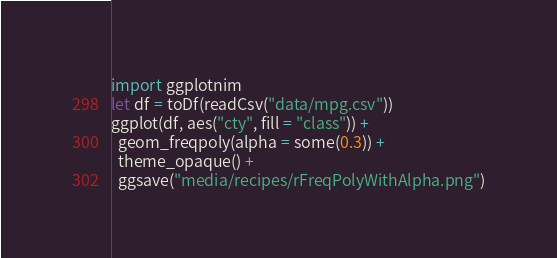Convert code to text. <code><loc_0><loc_0><loc_500><loc_500><_Nim_>import ggplotnim
let df = toDf(readCsv("data/mpg.csv"))
ggplot(df, aes("cty", fill = "class")) + 
  geom_freqpoly(alpha = some(0.3)) + 
  theme_opaque() +
  ggsave("media/recipes/rFreqPolyWithAlpha.png")
</code> 